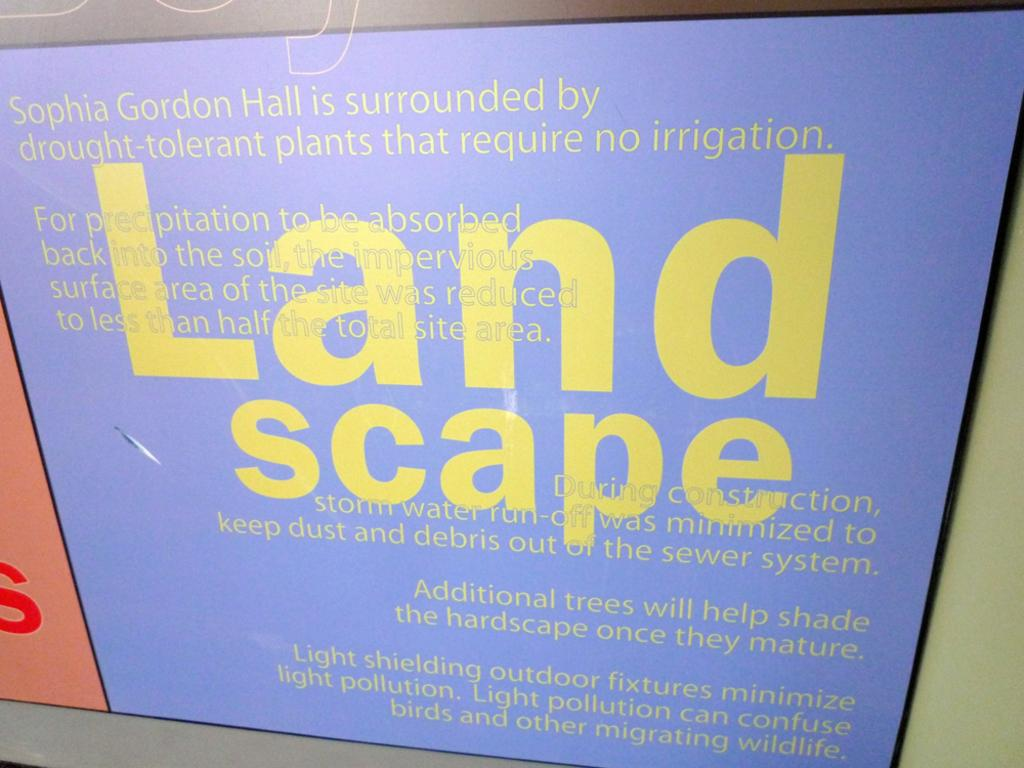<image>
Present a compact description of the photo's key features. A sign features the word "landscape" in large yellow letters. 